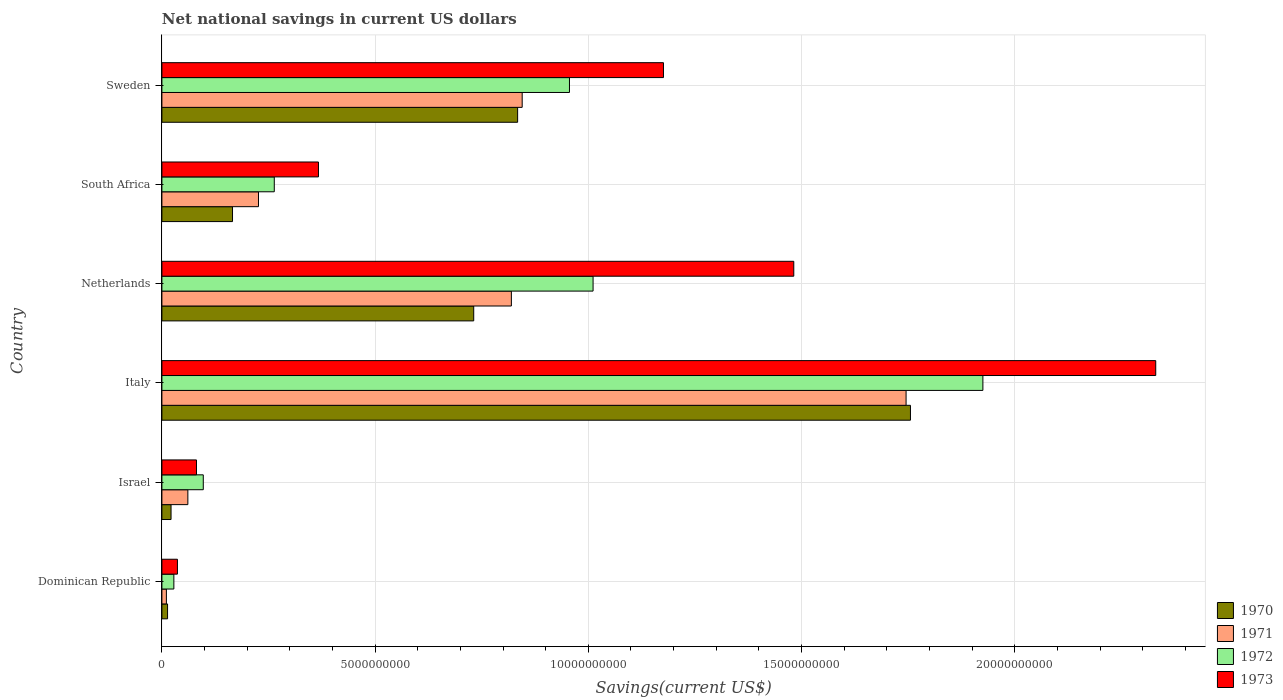How many different coloured bars are there?
Provide a succinct answer. 4. How many groups of bars are there?
Provide a short and direct response. 6. Are the number of bars on each tick of the Y-axis equal?
Ensure brevity in your answer.  Yes. What is the label of the 2nd group of bars from the top?
Keep it short and to the point. South Africa. In how many cases, is the number of bars for a given country not equal to the number of legend labels?
Your answer should be compact. 0. What is the net national savings in 1971 in Israel?
Offer a terse response. 6.09e+08. Across all countries, what is the maximum net national savings in 1973?
Offer a terse response. 2.33e+1. Across all countries, what is the minimum net national savings in 1973?
Ensure brevity in your answer.  3.65e+08. In which country was the net national savings in 1972 minimum?
Your answer should be compact. Dominican Republic. What is the total net national savings in 1970 in the graph?
Your response must be concise. 3.52e+1. What is the difference between the net national savings in 1971 in South Africa and that in Sweden?
Make the answer very short. -6.18e+09. What is the difference between the net national savings in 1970 in Dominican Republic and the net national savings in 1971 in South Africa?
Your answer should be very brief. -2.13e+09. What is the average net national savings in 1970 per country?
Provide a short and direct response. 5.87e+09. What is the difference between the net national savings in 1970 and net national savings in 1973 in Israel?
Your answer should be very brief. -5.96e+08. What is the ratio of the net national savings in 1971 in Dominican Republic to that in South Africa?
Make the answer very short. 0.05. Is the net national savings in 1973 in Israel less than that in South Africa?
Ensure brevity in your answer.  Yes. What is the difference between the highest and the second highest net national savings in 1972?
Make the answer very short. 9.14e+09. What is the difference between the highest and the lowest net national savings in 1973?
Your answer should be very brief. 2.29e+1. Are all the bars in the graph horizontal?
Provide a short and direct response. Yes. How many countries are there in the graph?
Keep it short and to the point. 6. What is the difference between two consecutive major ticks on the X-axis?
Provide a short and direct response. 5.00e+09. Are the values on the major ticks of X-axis written in scientific E-notation?
Your answer should be compact. No. Does the graph contain grids?
Your response must be concise. Yes. How many legend labels are there?
Offer a terse response. 4. How are the legend labels stacked?
Provide a short and direct response. Vertical. What is the title of the graph?
Your answer should be very brief. Net national savings in current US dollars. Does "1963" appear as one of the legend labels in the graph?
Make the answer very short. No. What is the label or title of the X-axis?
Keep it short and to the point. Savings(current US$). What is the label or title of the Y-axis?
Give a very brief answer. Country. What is the Savings(current US$) in 1970 in Dominican Republic?
Ensure brevity in your answer.  1.33e+08. What is the Savings(current US$) in 1971 in Dominican Republic?
Ensure brevity in your answer.  1.05e+08. What is the Savings(current US$) in 1972 in Dominican Republic?
Provide a short and direct response. 2.80e+08. What is the Savings(current US$) of 1973 in Dominican Republic?
Offer a terse response. 3.65e+08. What is the Savings(current US$) of 1970 in Israel?
Make the answer very short. 2.15e+08. What is the Savings(current US$) in 1971 in Israel?
Make the answer very short. 6.09e+08. What is the Savings(current US$) in 1972 in Israel?
Offer a very short reply. 9.71e+08. What is the Savings(current US$) in 1973 in Israel?
Your answer should be very brief. 8.11e+08. What is the Savings(current US$) in 1970 in Italy?
Offer a very short reply. 1.76e+1. What is the Savings(current US$) in 1971 in Italy?
Give a very brief answer. 1.75e+1. What is the Savings(current US$) of 1972 in Italy?
Offer a very short reply. 1.93e+1. What is the Savings(current US$) of 1973 in Italy?
Offer a terse response. 2.33e+1. What is the Savings(current US$) of 1970 in Netherlands?
Provide a succinct answer. 7.31e+09. What is the Savings(current US$) in 1971 in Netherlands?
Your answer should be very brief. 8.20e+09. What is the Savings(current US$) of 1972 in Netherlands?
Make the answer very short. 1.01e+1. What is the Savings(current US$) in 1973 in Netherlands?
Provide a short and direct response. 1.48e+1. What is the Savings(current US$) in 1970 in South Africa?
Provide a succinct answer. 1.66e+09. What is the Savings(current US$) in 1971 in South Africa?
Your answer should be compact. 2.27e+09. What is the Savings(current US$) in 1972 in South Africa?
Ensure brevity in your answer.  2.64e+09. What is the Savings(current US$) in 1973 in South Africa?
Provide a succinct answer. 3.67e+09. What is the Savings(current US$) in 1970 in Sweden?
Provide a succinct answer. 8.34e+09. What is the Savings(current US$) of 1971 in Sweden?
Keep it short and to the point. 8.45e+09. What is the Savings(current US$) of 1972 in Sweden?
Keep it short and to the point. 9.56e+09. What is the Savings(current US$) in 1973 in Sweden?
Your response must be concise. 1.18e+1. Across all countries, what is the maximum Savings(current US$) in 1970?
Offer a very short reply. 1.76e+1. Across all countries, what is the maximum Savings(current US$) in 1971?
Provide a succinct answer. 1.75e+1. Across all countries, what is the maximum Savings(current US$) in 1972?
Provide a short and direct response. 1.93e+1. Across all countries, what is the maximum Savings(current US$) in 1973?
Make the answer very short. 2.33e+1. Across all countries, what is the minimum Savings(current US$) of 1970?
Keep it short and to the point. 1.33e+08. Across all countries, what is the minimum Savings(current US$) in 1971?
Your answer should be very brief. 1.05e+08. Across all countries, what is the minimum Savings(current US$) of 1972?
Offer a terse response. 2.80e+08. Across all countries, what is the minimum Savings(current US$) in 1973?
Give a very brief answer. 3.65e+08. What is the total Savings(current US$) in 1970 in the graph?
Provide a succinct answer. 3.52e+1. What is the total Savings(current US$) in 1971 in the graph?
Your response must be concise. 3.71e+1. What is the total Savings(current US$) of 1972 in the graph?
Provide a succinct answer. 4.28e+1. What is the total Savings(current US$) in 1973 in the graph?
Provide a succinct answer. 5.47e+1. What is the difference between the Savings(current US$) of 1970 in Dominican Republic and that in Israel?
Provide a succinct answer. -8.19e+07. What is the difference between the Savings(current US$) of 1971 in Dominican Republic and that in Israel?
Keep it short and to the point. -5.03e+08. What is the difference between the Savings(current US$) of 1972 in Dominican Republic and that in Israel?
Make the answer very short. -6.90e+08. What is the difference between the Savings(current US$) of 1973 in Dominican Republic and that in Israel?
Ensure brevity in your answer.  -4.46e+08. What is the difference between the Savings(current US$) in 1970 in Dominican Republic and that in Italy?
Ensure brevity in your answer.  -1.74e+1. What is the difference between the Savings(current US$) in 1971 in Dominican Republic and that in Italy?
Provide a succinct answer. -1.73e+1. What is the difference between the Savings(current US$) in 1972 in Dominican Republic and that in Italy?
Your answer should be compact. -1.90e+1. What is the difference between the Savings(current US$) in 1973 in Dominican Republic and that in Italy?
Your response must be concise. -2.29e+1. What is the difference between the Savings(current US$) of 1970 in Dominican Republic and that in Netherlands?
Provide a succinct answer. -7.18e+09. What is the difference between the Savings(current US$) of 1971 in Dominican Republic and that in Netherlands?
Offer a terse response. -8.09e+09. What is the difference between the Savings(current US$) in 1972 in Dominican Republic and that in Netherlands?
Provide a succinct answer. -9.83e+09. What is the difference between the Savings(current US$) in 1973 in Dominican Republic and that in Netherlands?
Offer a terse response. -1.45e+1. What is the difference between the Savings(current US$) in 1970 in Dominican Republic and that in South Africa?
Give a very brief answer. -1.52e+09. What is the difference between the Savings(current US$) in 1971 in Dominican Republic and that in South Africa?
Ensure brevity in your answer.  -2.16e+09. What is the difference between the Savings(current US$) in 1972 in Dominican Republic and that in South Africa?
Offer a very short reply. -2.35e+09. What is the difference between the Savings(current US$) in 1973 in Dominican Republic and that in South Africa?
Your response must be concise. -3.31e+09. What is the difference between the Savings(current US$) in 1970 in Dominican Republic and that in Sweden?
Offer a very short reply. -8.21e+09. What is the difference between the Savings(current US$) in 1971 in Dominican Republic and that in Sweden?
Offer a terse response. -8.34e+09. What is the difference between the Savings(current US$) of 1972 in Dominican Republic and that in Sweden?
Provide a succinct answer. -9.28e+09. What is the difference between the Savings(current US$) in 1973 in Dominican Republic and that in Sweden?
Your answer should be very brief. -1.14e+1. What is the difference between the Savings(current US$) of 1970 in Israel and that in Italy?
Ensure brevity in your answer.  -1.73e+1. What is the difference between the Savings(current US$) of 1971 in Israel and that in Italy?
Ensure brevity in your answer.  -1.68e+1. What is the difference between the Savings(current US$) of 1972 in Israel and that in Italy?
Provide a short and direct response. -1.83e+1. What is the difference between the Savings(current US$) in 1973 in Israel and that in Italy?
Keep it short and to the point. -2.25e+1. What is the difference between the Savings(current US$) in 1970 in Israel and that in Netherlands?
Offer a very short reply. -7.10e+09. What is the difference between the Savings(current US$) in 1971 in Israel and that in Netherlands?
Provide a short and direct response. -7.59e+09. What is the difference between the Savings(current US$) of 1972 in Israel and that in Netherlands?
Give a very brief answer. -9.14e+09. What is the difference between the Savings(current US$) of 1973 in Israel and that in Netherlands?
Provide a short and direct response. -1.40e+1. What is the difference between the Savings(current US$) in 1970 in Israel and that in South Africa?
Your answer should be very brief. -1.44e+09. What is the difference between the Savings(current US$) in 1971 in Israel and that in South Africa?
Give a very brief answer. -1.66e+09. What is the difference between the Savings(current US$) of 1972 in Israel and that in South Africa?
Provide a succinct answer. -1.66e+09. What is the difference between the Savings(current US$) in 1973 in Israel and that in South Africa?
Make the answer very short. -2.86e+09. What is the difference between the Savings(current US$) in 1970 in Israel and that in Sweden?
Offer a very short reply. -8.13e+09. What is the difference between the Savings(current US$) of 1971 in Israel and that in Sweden?
Your response must be concise. -7.84e+09. What is the difference between the Savings(current US$) of 1972 in Israel and that in Sweden?
Your answer should be very brief. -8.59e+09. What is the difference between the Savings(current US$) in 1973 in Israel and that in Sweden?
Your answer should be very brief. -1.10e+1. What is the difference between the Savings(current US$) of 1970 in Italy and that in Netherlands?
Keep it short and to the point. 1.02e+1. What is the difference between the Savings(current US$) in 1971 in Italy and that in Netherlands?
Make the answer very short. 9.26e+09. What is the difference between the Savings(current US$) of 1972 in Italy and that in Netherlands?
Give a very brief answer. 9.14e+09. What is the difference between the Savings(current US$) in 1973 in Italy and that in Netherlands?
Make the answer very short. 8.49e+09. What is the difference between the Savings(current US$) in 1970 in Italy and that in South Africa?
Ensure brevity in your answer.  1.59e+1. What is the difference between the Savings(current US$) of 1971 in Italy and that in South Africa?
Ensure brevity in your answer.  1.52e+1. What is the difference between the Savings(current US$) in 1972 in Italy and that in South Africa?
Your answer should be very brief. 1.66e+1. What is the difference between the Savings(current US$) of 1973 in Italy and that in South Africa?
Provide a short and direct response. 1.96e+1. What is the difference between the Savings(current US$) in 1970 in Italy and that in Sweden?
Your response must be concise. 9.21e+09. What is the difference between the Savings(current US$) of 1971 in Italy and that in Sweden?
Keep it short and to the point. 9.00e+09. What is the difference between the Savings(current US$) of 1972 in Italy and that in Sweden?
Your answer should be very brief. 9.70e+09. What is the difference between the Savings(current US$) of 1973 in Italy and that in Sweden?
Make the answer very short. 1.15e+1. What is the difference between the Savings(current US$) of 1970 in Netherlands and that in South Africa?
Offer a very short reply. 5.66e+09. What is the difference between the Savings(current US$) in 1971 in Netherlands and that in South Africa?
Ensure brevity in your answer.  5.93e+09. What is the difference between the Savings(current US$) in 1972 in Netherlands and that in South Africa?
Your answer should be very brief. 7.48e+09. What is the difference between the Savings(current US$) in 1973 in Netherlands and that in South Africa?
Your response must be concise. 1.11e+1. What is the difference between the Savings(current US$) of 1970 in Netherlands and that in Sweden?
Make the answer very short. -1.03e+09. What is the difference between the Savings(current US$) of 1971 in Netherlands and that in Sweden?
Make the answer very short. -2.53e+08. What is the difference between the Savings(current US$) of 1972 in Netherlands and that in Sweden?
Your answer should be compact. 5.54e+08. What is the difference between the Savings(current US$) in 1973 in Netherlands and that in Sweden?
Provide a short and direct response. 3.06e+09. What is the difference between the Savings(current US$) of 1970 in South Africa and that in Sweden?
Provide a short and direct response. -6.69e+09. What is the difference between the Savings(current US$) in 1971 in South Africa and that in Sweden?
Keep it short and to the point. -6.18e+09. What is the difference between the Savings(current US$) of 1972 in South Africa and that in Sweden?
Keep it short and to the point. -6.92e+09. What is the difference between the Savings(current US$) of 1973 in South Africa and that in Sweden?
Your answer should be very brief. -8.09e+09. What is the difference between the Savings(current US$) in 1970 in Dominican Republic and the Savings(current US$) in 1971 in Israel?
Give a very brief answer. -4.76e+08. What is the difference between the Savings(current US$) of 1970 in Dominican Republic and the Savings(current US$) of 1972 in Israel?
Your answer should be compact. -8.38e+08. What is the difference between the Savings(current US$) of 1970 in Dominican Republic and the Savings(current US$) of 1973 in Israel?
Offer a terse response. -6.78e+08. What is the difference between the Savings(current US$) of 1971 in Dominican Republic and the Savings(current US$) of 1972 in Israel?
Provide a short and direct response. -8.65e+08. What is the difference between the Savings(current US$) in 1971 in Dominican Republic and the Savings(current US$) in 1973 in Israel?
Offer a terse response. -7.05e+08. What is the difference between the Savings(current US$) in 1972 in Dominican Republic and the Savings(current US$) in 1973 in Israel?
Offer a terse response. -5.30e+08. What is the difference between the Savings(current US$) of 1970 in Dominican Republic and the Savings(current US$) of 1971 in Italy?
Give a very brief answer. -1.73e+1. What is the difference between the Savings(current US$) in 1970 in Dominican Republic and the Savings(current US$) in 1972 in Italy?
Your answer should be very brief. -1.91e+1. What is the difference between the Savings(current US$) of 1970 in Dominican Republic and the Savings(current US$) of 1973 in Italy?
Offer a terse response. -2.32e+1. What is the difference between the Savings(current US$) of 1971 in Dominican Republic and the Savings(current US$) of 1972 in Italy?
Provide a succinct answer. -1.91e+1. What is the difference between the Savings(current US$) in 1971 in Dominican Republic and the Savings(current US$) in 1973 in Italy?
Make the answer very short. -2.32e+1. What is the difference between the Savings(current US$) of 1972 in Dominican Republic and the Savings(current US$) of 1973 in Italy?
Make the answer very short. -2.30e+1. What is the difference between the Savings(current US$) of 1970 in Dominican Republic and the Savings(current US$) of 1971 in Netherlands?
Provide a succinct answer. -8.06e+09. What is the difference between the Savings(current US$) in 1970 in Dominican Republic and the Savings(current US$) in 1972 in Netherlands?
Your answer should be compact. -9.98e+09. What is the difference between the Savings(current US$) of 1970 in Dominican Republic and the Savings(current US$) of 1973 in Netherlands?
Keep it short and to the point. -1.47e+1. What is the difference between the Savings(current US$) of 1971 in Dominican Republic and the Savings(current US$) of 1972 in Netherlands?
Offer a very short reply. -1.00e+1. What is the difference between the Savings(current US$) in 1971 in Dominican Republic and the Savings(current US$) in 1973 in Netherlands?
Make the answer very short. -1.47e+1. What is the difference between the Savings(current US$) in 1972 in Dominican Republic and the Savings(current US$) in 1973 in Netherlands?
Offer a terse response. -1.45e+1. What is the difference between the Savings(current US$) of 1970 in Dominican Republic and the Savings(current US$) of 1971 in South Africa?
Your answer should be very brief. -2.13e+09. What is the difference between the Savings(current US$) of 1970 in Dominican Republic and the Savings(current US$) of 1972 in South Africa?
Make the answer very short. -2.50e+09. What is the difference between the Savings(current US$) of 1970 in Dominican Republic and the Savings(current US$) of 1973 in South Africa?
Offer a very short reply. -3.54e+09. What is the difference between the Savings(current US$) in 1971 in Dominican Republic and the Savings(current US$) in 1972 in South Africa?
Give a very brief answer. -2.53e+09. What is the difference between the Savings(current US$) in 1971 in Dominican Republic and the Savings(current US$) in 1973 in South Africa?
Provide a short and direct response. -3.57e+09. What is the difference between the Savings(current US$) in 1972 in Dominican Republic and the Savings(current US$) in 1973 in South Africa?
Make the answer very short. -3.39e+09. What is the difference between the Savings(current US$) of 1970 in Dominican Republic and the Savings(current US$) of 1971 in Sweden?
Keep it short and to the point. -8.32e+09. What is the difference between the Savings(current US$) in 1970 in Dominican Republic and the Savings(current US$) in 1972 in Sweden?
Ensure brevity in your answer.  -9.43e+09. What is the difference between the Savings(current US$) of 1970 in Dominican Republic and the Savings(current US$) of 1973 in Sweden?
Offer a terse response. -1.16e+1. What is the difference between the Savings(current US$) of 1971 in Dominican Republic and the Savings(current US$) of 1972 in Sweden?
Your response must be concise. -9.45e+09. What is the difference between the Savings(current US$) in 1971 in Dominican Republic and the Savings(current US$) in 1973 in Sweden?
Provide a short and direct response. -1.17e+1. What is the difference between the Savings(current US$) in 1972 in Dominican Republic and the Savings(current US$) in 1973 in Sweden?
Give a very brief answer. -1.15e+1. What is the difference between the Savings(current US$) in 1970 in Israel and the Savings(current US$) in 1971 in Italy?
Make the answer very short. -1.72e+1. What is the difference between the Savings(current US$) in 1970 in Israel and the Savings(current US$) in 1972 in Italy?
Offer a very short reply. -1.90e+1. What is the difference between the Savings(current US$) in 1970 in Israel and the Savings(current US$) in 1973 in Italy?
Provide a short and direct response. -2.31e+1. What is the difference between the Savings(current US$) of 1971 in Israel and the Savings(current US$) of 1972 in Italy?
Your response must be concise. -1.86e+1. What is the difference between the Savings(current US$) of 1971 in Israel and the Savings(current US$) of 1973 in Italy?
Provide a short and direct response. -2.27e+1. What is the difference between the Savings(current US$) in 1972 in Israel and the Savings(current US$) in 1973 in Italy?
Ensure brevity in your answer.  -2.23e+1. What is the difference between the Savings(current US$) in 1970 in Israel and the Savings(current US$) in 1971 in Netherlands?
Ensure brevity in your answer.  -7.98e+09. What is the difference between the Savings(current US$) in 1970 in Israel and the Savings(current US$) in 1972 in Netherlands?
Offer a terse response. -9.90e+09. What is the difference between the Savings(current US$) of 1970 in Israel and the Savings(current US$) of 1973 in Netherlands?
Your answer should be very brief. -1.46e+1. What is the difference between the Savings(current US$) in 1971 in Israel and the Savings(current US$) in 1972 in Netherlands?
Give a very brief answer. -9.50e+09. What is the difference between the Savings(current US$) of 1971 in Israel and the Savings(current US$) of 1973 in Netherlands?
Your response must be concise. -1.42e+1. What is the difference between the Savings(current US$) in 1972 in Israel and the Savings(current US$) in 1973 in Netherlands?
Your answer should be compact. -1.38e+1. What is the difference between the Savings(current US$) in 1970 in Israel and the Savings(current US$) in 1971 in South Africa?
Your response must be concise. -2.05e+09. What is the difference between the Savings(current US$) in 1970 in Israel and the Savings(current US$) in 1972 in South Africa?
Your answer should be very brief. -2.42e+09. What is the difference between the Savings(current US$) of 1970 in Israel and the Savings(current US$) of 1973 in South Africa?
Ensure brevity in your answer.  -3.46e+09. What is the difference between the Savings(current US$) of 1971 in Israel and the Savings(current US$) of 1972 in South Africa?
Provide a short and direct response. -2.03e+09. What is the difference between the Savings(current US$) of 1971 in Israel and the Savings(current US$) of 1973 in South Africa?
Offer a very short reply. -3.06e+09. What is the difference between the Savings(current US$) in 1972 in Israel and the Savings(current US$) in 1973 in South Africa?
Ensure brevity in your answer.  -2.70e+09. What is the difference between the Savings(current US$) in 1970 in Israel and the Savings(current US$) in 1971 in Sweden?
Provide a succinct answer. -8.23e+09. What is the difference between the Savings(current US$) of 1970 in Israel and the Savings(current US$) of 1972 in Sweden?
Make the answer very short. -9.34e+09. What is the difference between the Savings(current US$) in 1970 in Israel and the Savings(current US$) in 1973 in Sweden?
Give a very brief answer. -1.15e+1. What is the difference between the Savings(current US$) of 1971 in Israel and the Savings(current US$) of 1972 in Sweden?
Provide a short and direct response. -8.95e+09. What is the difference between the Savings(current US$) in 1971 in Israel and the Savings(current US$) in 1973 in Sweden?
Make the answer very short. -1.12e+1. What is the difference between the Savings(current US$) of 1972 in Israel and the Savings(current US$) of 1973 in Sweden?
Your answer should be very brief. -1.08e+1. What is the difference between the Savings(current US$) in 1970 in Italy and the Savings(current US$) in 1971 in Netherlands?
Keep it short and to the point. 9.36e+09. What is the difference between the Savings(current US$) of 1970 in Italy and the Savings(current US$) of 1972 in Netherlands?
Your response must be concise. 7.44e+09. What is the difference between the Savings(current US$) in 1970 in Italy and the Savings(current US$) in 1973 in Netherlands?
Keep it short and to the point. 2.74e+09. What is the difference between the Savings(current US$) in 1971 in Italy and the Savings(current US$) in 1972 in Netherlands?
Your answer should be compact. 7.34e+09. What is the difference between the Savings(current US$) of 1971 in Italy and the Savings(current US$) of 1973 in Netherlands?
Keep it short and to the point. 2.63e+09. What is the difference between the Savings(current US$) in 1972 in Italy and the Savings(current US$) in 1973 in Netherlands?
Provide a short and direct response. 4.44e+09. What is the difference between the Savings(current US$) in 1970 in Italy and the Savings(current US$) in 1971 in South Africa?
Make the answer very short. 1.53e+1. What is the difference between the Savings(current US$) in 1970 in Italy and the Savings(current US$) in 1972 in South Africa?
Offer a terse response. 1.49e+1. What is the difference between the Savings(current US$) of 1970 in Italy and the Savings(current US$) of 1973 in South Africa?
Ensure brevity in your answer.  1.39e+1. What is the difference between the Savings(current US$) of 1971 in Italy and the Savings(current US$) of 1972 in South Africa?
Offer a terse response. 1.48e+1. What is the difference between the Savings(current US$) of 1971 in Italy and the Savings(current US$) of 1973 in South Africa?
Give a very brief answer. 1.38e+1. What is the difference between the Savings(current US$) of 1972 in Italy and the Savings(current US$) of 1973 in South Africa?
Your response must be concise. 1.56e+1. What is the difference between the Savings(current US$) in 1970 in Italy and the Savings(current US$) in 1971 in Sweden?
Offer a very short reply. 9.11e+09. What is the difference between the Savings(current US$) in 1970 in Italy and the Savings(current US$) in 1972 in Sweden?
Ensure brevity in your answer.  8.00e+09. What is the difference between the Savings(current US$) of 1970 in Italy and the Savings(current US$) of 1973 in Sweden?
Provide a short and direct response. 5.79e+09. What is the difference between the Savings(current US$) of 1971 in Italy and the Savings(current US$) of 1972 in Sweden?
Make the answer very short. 7.89e+09. What is the difference between the Savings(current US$) in 1971 in Italy and the Savings(current US$) in 1973 in Sweden?
Your response must be concise. 5.69e+09. What is the difference between the Savings(current US$) of 1972 in Italy and the Savings(current US$) of 1973 in Sweden?
Offer a terse response. 7.49e+09. What is the difference between the Savings(current US$) of 1970 in Netherlands and the Savings(current US$) of 1971 in South Africa?
Provide a short and direct response. 5.05e+09. What is the difference between the Savings(current US$) of 1970 in Netherlands and the Savings(current US$) of 1972 in South Africa?
Make the answer very short. 4.68e+09. What is the difference between the Savings(current US$) in 1970 in Netherlands and the Savings(current US$) in 1973 in South Africa?
Make the answer very short. 3.64e+09. What is the difference between the Savings(current US$) of 1971 in Netherlands and the Savings(current US$) of 1972 in South Africa?
Offer a terse response. 5.56e+09. What is the difference between the Savings(current US$) in 1971 in Netherlands and the Savings(current US$) in 1973 in South Africa?
Make the answer very short. 4.52e+09. What is the difference between the Savings(current US$) in 1972 in Netherlands and the Savings(current US$) in 1973 in South Africa?
Ensure brevity in your answer.  6.44e+09. What is the difference between the Savings(current US$) of 1970 in Netherlands and the Savings(current US$) of 1971 in Sweden?
Your response must be concise. -1.14e+09. What is the difference between the Savings(current US$) of 1970 in Netherlands and the Savings(current US$) of 1972 in Sweden?
Keep it short and to the point. -2.25e+09. What is the difference between the Savings(current US$) in 1970 in Netherlands and the Savings(current US$) in 1973 in Sweden?
Offer a very short reply. -4.45e+09. What is the difference between the Savings(current US$) of 1971 in Netherlands and the Savings(current US$) of 1972 in Sweden?
Make the answer very short. -1.36e+09. What is the difference between the Savings(current US$) of 1971 in Netherlands and the Savings(current US$) of 1973 in Sweden?
Offer a very short reply. -3.57e+09. What is the difference between the Savings(current US$) in 1972 in Netherlands and the Savings(current US$) in 1973 in Sweden?
Offer a very short reply. -1.65e+09. What is the difference between the Savings(current US$) of 1970 in South Africa and the Savings(current US$) of 1971 in Sweden?
Provide a succinct answer. -6.79e+09. What is the difference between the Savings(current US$) of 1970 in South Africa and the Savings(current US$) of 1972 in Sweden?
Your answer should be very brief. -7.90e+09. What is the difference between the Savings(current US$) in 1970 in South Africa and the Savings(current US$) in 1973 in Sweden?
Provide a short and direct response. -1.01e+1. What is the difference between the Savings(current US$) of 1971 in South Africa and the Savings(current US$) of 1972 in Sweden?
Ensure brevity in your answer.  -7.29e+09. What is the difference between the Savings(current US$) in 1971 in South Africa and the Savings(current US$) in 1973 in Sweden?
Offer a terse response. -9.50e+09. What is the difference between the Savings(current US$) in 1972 in South Africa and the Savings(current US$) in 1973 in Sweden?
Provide a succinct answer. -9.13e+09. What is the average Savings(current US$) in 1970 per country?
Make the answer very short. 5.87e+09. What is the average Savings(current US$) in 1971 per country?
Provide a short and direct response. 6.18e+09. What is the average Savings(current US$) in 1972 per country?
Ensure brevity in your answer.  7.14e+09. What is the average Savings(current US$) of 1973 per country?
Your answer should be very brief. 9.12e+09. What is the difference between the Savings(current US$) of 1970 and Savings(current US$) of 1971 in Dominican Republic?
Your response must be concise. 2.74e+07. What is the difference between the Savings(current US$) of 1970 and Savings(current US$) of 1972 in Dominican Republic?
Your answer should be compact. -1.48e+08. What is the difference between the Savings(current US$) in 1970 and Savings(current US$) in 1973 in Dominican Republic?
Provide a short and direct response. -2.32e+08. What is the difference between the Savings(current US$) of 1971 and Savings(current US$) of 1972 in Dominican Republic?
Provide a short and direct response. -1.75e+08. What is the difference between the Savings(current US$) in 1971 and Savings(current US$) in 1973 in Dominican Republic?
Offer a very short reply. -2.59e+08. What is the difference between the Savings(current US$) of 1972 and Savings(current US$) of 1973 in Dominican Republic?
Make the answer very short. -8.40e+07. What is the difference between the Savings(current US$) of 1970 and Savings(current US$) of 1971 in Israel?
Offer a very short reply. -3.94e+08. What is the difference between the Savings(current US$) in 1970 and Savings(current US$) in 1972 in Israel?
Your response must be concise. -7.56e+08. What is the difference between the Savings(current US$) of 1970 and Savings(current US$) of 1973 in Israel?
Provide a short and direct response. -5.96e+08. What is the difference between the Savings(current US$) of 1971 and Savings(current US$) of 1972 in Israel?
Provide a short and direct response. -3.62e+08. What is the difference between the Savings(current US$) of 1971 and Savings(current US$) of 1973 in Israel?
Make the answer very short. -2.02e+08. What is the difference between the Savings(current US$) of 1972 and Savings(current US$) of 1973 in Israel?
Offer a terse response. 1.60e+08. What is the difference between the Savings(current US$) of 1970 and Savings(current US$) of 1971 in Italy?
Make the answer very short. 1.03e+08. What is the difference between the Savings(current US$) of 1970 and Savings(current US$) of 1972 in Italy?
Provide a succinct answer. -1.70e+09. What is the difference between the Savings(current US$) of 1970 and Savings(current US$) of 1973 in Italy?
Make the answer very short. -5.75e+09. What is the difference between the Savings(current US$) of 1971 and Savings(current US$) of 1972 in Italy?
Make the answer very short. -1.80e+09. What is the difference between the Savings(current US$) in 1971 and Savings(current US$) in 1973 in Italy?
Your answer should be compact. -5.86e+09. What is the difference between the Savings(current US$) in 1972 and Savings(current US$) in 1973 in Italy?
Your response must be concise. -4.05e+09. What is the difference between the Savings(current US$) of 1970 and Savings(current US$) of 1971 in Netherlands?
Keep it short and to the point. -8.83e+08. What is the difference between the Savings(current US$) of 1970 and Savings(current US$) of 1972 in Netherlands?
Your answer should be compact. -2.80e+09. What is the difference between the Savings(current US$) of 1970 and Savings(current US$) of 1973 in Netherlands?
Your answer should be very brief. -7.51e+09. What is the difference between the Savings(current US$) in 1971 and Savings(current US$) in 1972 in Netherlands?
Provide a succinct answer. -1.92e+09. What is the difference between the Savings(current US$) in 1971 and Savings(current US$) in 1973 in Netherlands?
Ensure brevity in your answer.  -6.62e+09. What is the difference between the Savings(current US$) of 1972 and Savings(current US$) of 1973 in Netherlands?
Provide a succinct answer. -4.71e+09. What is the difference between the Savings(current US$) of 1970 and Savings(current US$) of 1971 in South Africa?
Your answer should be compact. -6.09e+08. What is the difference between the Savings(current US$) in 1970 and Savings(current US$) in 1972 in South Africa?
Make the answer very short. -9.79e+08. What is the difference between the Savings(current US$) in 1970 and Savings(current US$) in 1973 in South Africa?
Your answer should be very brief. -2.02e+09. What is the difference between the Savings(current US$) in 1971 and Savings(current US$) in 1972 in South Africa?
Keep it short and to the point. -3.70e+08. What is the difference between the Savings(current US$) in 1971 and Savings(current US$) in 1973 in South Africa?
Your response must be concise. -1.41e+09. What is the difference between the Savings(current US$) in 1972 and Savings(current US$) in 1973 in South Africa?
Give a very brief answer. -1.04e+09. What is the difference between the Savings(current US$) of 1970 and Savings(current US$) of 1971 in Sweden?
Make the answer very short. -1.07e+08. What is the difference between the Savings(current US$) in 1970 and Savings(current US$) in 1972 in Sweden?
Provide a short and direct response. -1.22e+09. What is the difference between the Savings(current US$) in 1970 and Savings(current US$) in 1973 in Sweden?
Make the answer very short. -3.42e+09. What is the difference between the Savings(current US$) in 1971 and Savings(current US$) in 1972 in Sweden?
Give a very brief answer. -1.11e+09. What is the difference between the Savings(current US$) in 1971 and Savings(current US$) in 1973 in Sweden?
Give a very brief answer. -3.31e+09. What is the difference between the Savings(current US$) of 1972 and Savings(current US$) of 1973 in Sweden?
Provide a succinct answer. -2.20e+09. What is the ratio of the Savings(current US$) of 1970 in Dominican Republic to that in Israel?
Your response must be concise. 0.62. What is the ratio of the Savings(current US$) of 1971 in Dominican Republic to that in Israel?
Offer a very short reply. 0.17. What is the ratio of the Savings(current US$) in 1972 in Dominican Republic to that in Israel?
Your response must be concise. 0.29. What is the ratio of the Savings(current US$) of 1973 in Dominican Republic to that in Israel?
Make the answer very short. 0.45. What is the ratio of the Savings(current US$) of 1970 in Dominican Republic to that in Italy?
Your response must be concise. 0.01. What is the ratio of the Savings(current US$) in 1971 in Dominican Republic to that in Italy?
Your answer should be very brief. 0.01. What is the ratio of the Savings(current US$) in 1972 in Dominican Republic to that in Italy?
Your response must be concise. 0.01. What is the ratio of the Savings(current US$) in 1973 in Dominican Republic to that in Italy?
Offer a very short reply. 0.02. What is the ratio of the Savings(current US$) of 1970 in Dominican Republic to that in Netherlands?
Provide a succinct answer. 0.02. What is the ratio of the Savings(current US$) in 1971 in Dominican Republic to that in Netherlands?
Ensure brevity in your answer.  0.01. What is the ratio of the Savings(current US$) of 1972 in Dominican Republic to that in Netherlands?
Provide a short and direct response. 0.03. What is the ratio of the Savings(current US$) in 1973 in Dominican Republic to that in Netherlands?
Make the answer very short. 0.02. What is the ratio of the Savings(current US$) of 1970 in Dominican Republic to that in South Africa?
Provide a succinct answer. 0.08. What is the ratio of the Savings(current US$) of 1971 in Dominican Republic to that in South Africa?
Your answer should be compact. 0.05. What is the ratio of the Savings(current US$) in 1972 in Dominican Republic to that in South Africa?
Make the answer very short. 0.11. What is the ratio of the Savings(current US$) in 1973 in Dominican Republic to that in South Africa?
Offer a very short reply. 0.1. What is the ratio of the Savings(current US$) in 1970 in Dominican Republic to that in Sweden?
Offer a very short reply. 0.02. What is the ratio of the Savings(current US$) of 1971 in Dominican Republic to that in Sweden?
Provide a succinct answer. 0.01. What is the ratio of the Savings(current US$) of 1972 in Dominican Republic to that in Sweden?
Provide a succinct answer. 0.03. What is the ratio of the Savings(current US$) in 1973 in Dominican Republic to that in Sweden?
Provide a short and direct response. 0.03. What is the ratio of the Savings(current US$) in 1970 in Israel to that in Italy?
Offer a terse response. 0.01. What is the ratio of the Savings(current US$) of 1971 in Israel to that in Italy?
Make the answer very short. 0.03. What is the ratio of the Savings(current US$) in 1972 in Israel to that in Italy?
Give a very brief answer. 0.05. What is the ratio of the Savings(current US$) of 1973 in Israel to that in Italy?
Give a very brief answer. 0.03. What is the ratio of the Savings(current US$) of 1970 in Israel to that in Netherlands?
Make the answer very short. 0.03. What is the ratio of the Savings(current US$) in 1971 in Israel to that in Netherlands?
Ensure brevity in your answer.  0.07. What is the ratio of the Savings(current US$) in 1972 in Israel to that in Netherlands?
Provide a short and direct response. 0.1. What is the ratio of the Savings(current US$) in 1973 in Israel to that in Netherlands?
Keep it short and to the point. 0.05. What is the ratio of the Savings(current US$) in 1970 in Israel to that in South Africa?
Offer a terse response. 0.13. What is the ratio of the Savings(current US$) in 1971 in Israel to that in South Africa?
Offer a terse response. 0.27. What is the ratio of the Savings(current US$) in 1972 in Israel to that in South Africa?
Provide a succinct answer. 0.37. What is the ratio of the Savings(current US$) in 1973 in Israel to that in South Africa?
Offer a very short reply. 0.22. What is the ratio of the Savings(current US$) in 1970 in Israel to that in Sweden?
Offer a terse response. 0.03. What is the ratio of the Savings(current US$) of 1971 in Israel to that in Sweden?
Your answer should be compact. 0.07. What is the ratio of the Savings(current US$) in 1972 in Israel to that in Sweden?
Ensure brevity in your answer.  0.1. What is the ratio of the Savings(current US$) of 1973 in Israel to that in Sweden?
Ensure brevity in your answer.  0.07. What is the ratio of the Savings(current US$) of 1970 in Italy to that in Netherlands?
Provide a short and direct response. 2.4. What is the ratio of the Savings(current US$) in 1971 in Italy to that in Netherlands?
Keep it short and to the point. 2.13. What is the ratio of the Savings(current US$) in 1972 in Italy to that in Netherlands?
Ensure brevity in your answer.  1.9. What is the ratio of the Savings(current US$) in 1973 in Italy to that in Netherlands?
Provide a succinct answer. 1.57. What is the ratio of the Savings(current US$) of 1970 in Italy to that in South Africa?
Offer a terse response. 10.6. What is the ratio of the Savings(current US$) of 1971 in Italy to that in South Africa?
Provide a short and direct response. 7.7. What is the ratio of the Savings(current US$) of 1972 in Italy to that in South Africa?
Ensure brevity in your answer.  7.31. What is the ratio of the Savings(current US$) in 1973 in Italy to that in South Africa?
Your answer should be very brief. 6.35. What is the ratio of the Savings(current US$) in 1970 in Italy to that in Sweden?
Provide a short and direct response. 2.1. What is the ratio of the Savings(current US$) in 1971 in Italy to that in Sweden?
Your response must be concise. 2.07. What is the ratio of the Savings(current US$) of 1972 in Italy to that in Sweden?
Offer a very short reply. 2.01. What is the ratio of the Savings(current US$) in 1973 in Italy to that in Sweden?
Offer a terse response. 1.98. What is the ratio of the Savings(current US$) in 1970 in Netherlands to that in South Africa?
Provide a succinct answer. 4.42. What is the ratio of the Savings(current US$) of 1971 in Netherlands to that in South Africa?
Give a very brief answer. 3.62. What is the ratio of the Savings(current US$) of 1972 in Netherlands to that in South Africa?
Give a very brief answer. 3.84. What is the ratio of the Savings(current US$) of 1973 in Netherlands to that in South Africa?
Your answer should be compact. 4.04. What is the ratio of the Savings(current US$) in 1970 in Netherlands to that in Sweden?
Make the answer very short. 0.88. What is the ratio of the Savings(current US$) of 1972 in Netherlands to that in Sweden?
Make the answer very short. 1.06. What is the ratio of the Savings(current US$) of 1973 in Netherlands to that in Sweden?
Ensure brevity in your answer.  1.26. What is the ratio of the Savings(current US$) of 1970 in South Africa to that in Sweden?
Give a very brief answer. 0.2. What is the ratio of the Savings(current US$) of 1971 in South Africa to that in Sweden?
Your response must be concise. 0.27. What is the ratio of the Savings(current US$) in 1972 in South Africa to that in Sweden?
Your answer should be compact. 0.28. What is the ratio of the Savings(current US$) in 1973 in South Africa to that in Sweden?
Offer a terse response. 0.31. What is the difference between the highest and the second highest Savings(current US$) of 1970?
Keep it short and to the point. 9.21e+09. What is the difference between the highest and the second highest Savings(current US$) of 1971?
Offer a very short reply. 9.00e+09. What is the difference between the highest and the second highest Savings(current US$) in 1972?
Your answer should be very brief. 9.14e+09. What is the difference between the highest and the second highest Savings(current US$) of 1973?
Provide a short and direct response. 8.49e+09. What is the difference between the highest and the lowest Savings(current US$) in 1970?
Make the answer very short. 1.74e+1. What is the difference between the highest and the lowest Savings(current US$) of 1971?
Give a very brief answer. 1.73e+1. What is the difference between the highest and the lowest Savings(current US$) in 1972?
Provide a short and direct response. 1.90e+1. What is the difference between the highest and the lowest Savings(current US$) in 1973?
Your answer should be compact. 2.29e+1. 